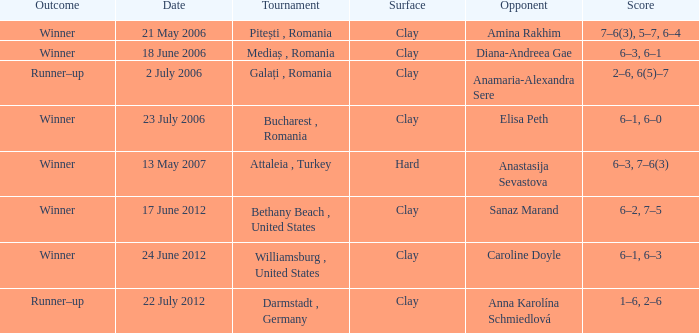What kind of contest occurred on the 21st of may, 2006? Pitești , Romania. 